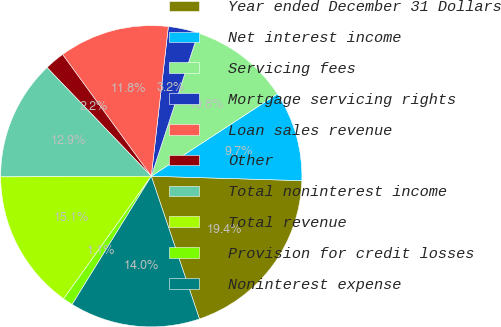Convert chart to OTSL. <chart><loc_0><loc_0><loc_500><loc_500><pie_chart><fcel>Year ended December 31 Dollars<fcel>Net interest income<fcel>Servicing fees<fcel>Mortgage servicing rights<fcel>Loan sales revenue<fcel>Other<fcel>Total noninterest income<fcel>Total revenue<fcel>Provision for credit losses<fcel>Noninterest expense<nl><fcel>19.35%<fcel>9.68%<fcel>10.75%<fcel>3.23%<fcel>11.83%<fcel>2.15%<fcel>12.9%<fcel>15.05%<fcel>1.08%<fcel>13.98%<nl></chart> 